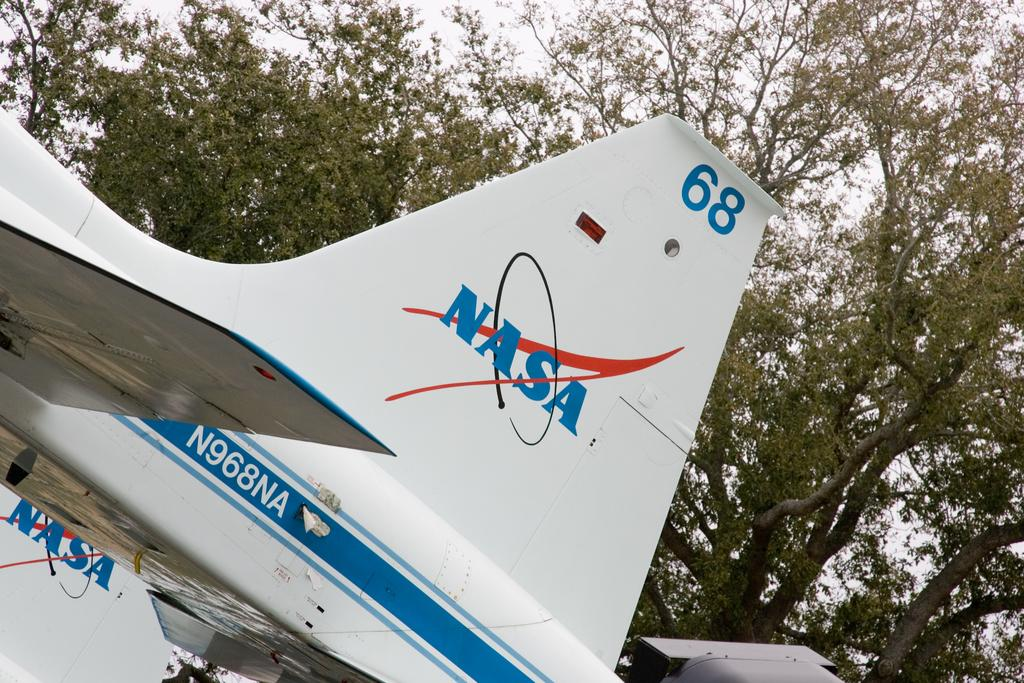<image>
Render a clear and concise summary of the photo. A Nasa sign on the plane with 68 on top 